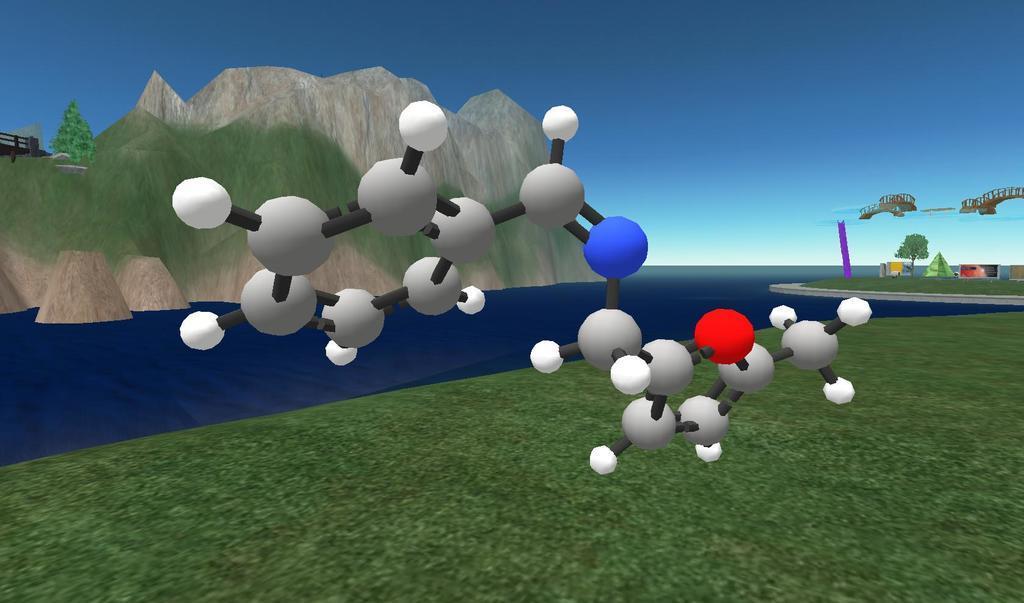Can you describe this image briefly? This image looks like animated. At the bottom, there is green grass. In the middle, there is water. On the left, we can see the mountains. On the right, there is a tent along with a bridge. At the top, there is sky. In the front, there are objects which look like balls. 